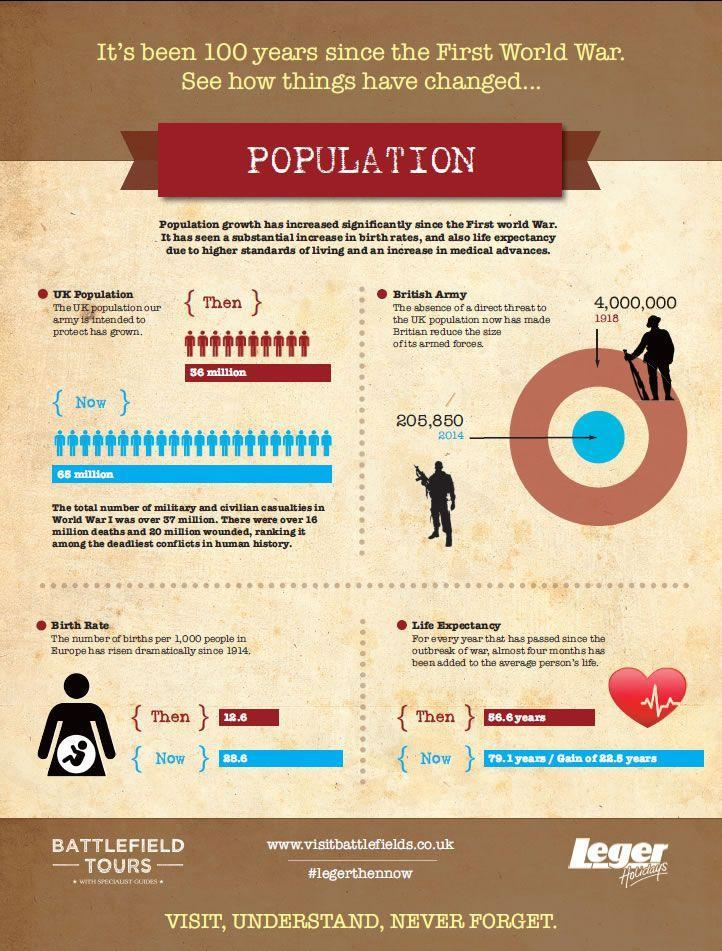What was the life expectancy in the UK in 1918?
Answer the question with a short phrase. 56.6 years What is the birth rate in the UK in 2014? 28.6 What was the number of British armed forces in 1918? 4,000,000 